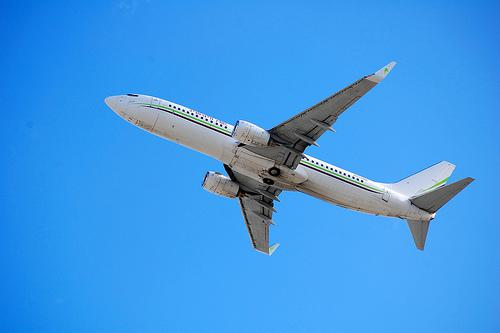Could you describe the weather conditions based on the image? The sky appears clear and free of clouds, suggesting that the weather conditions are favorable for flying, with good visibility. 